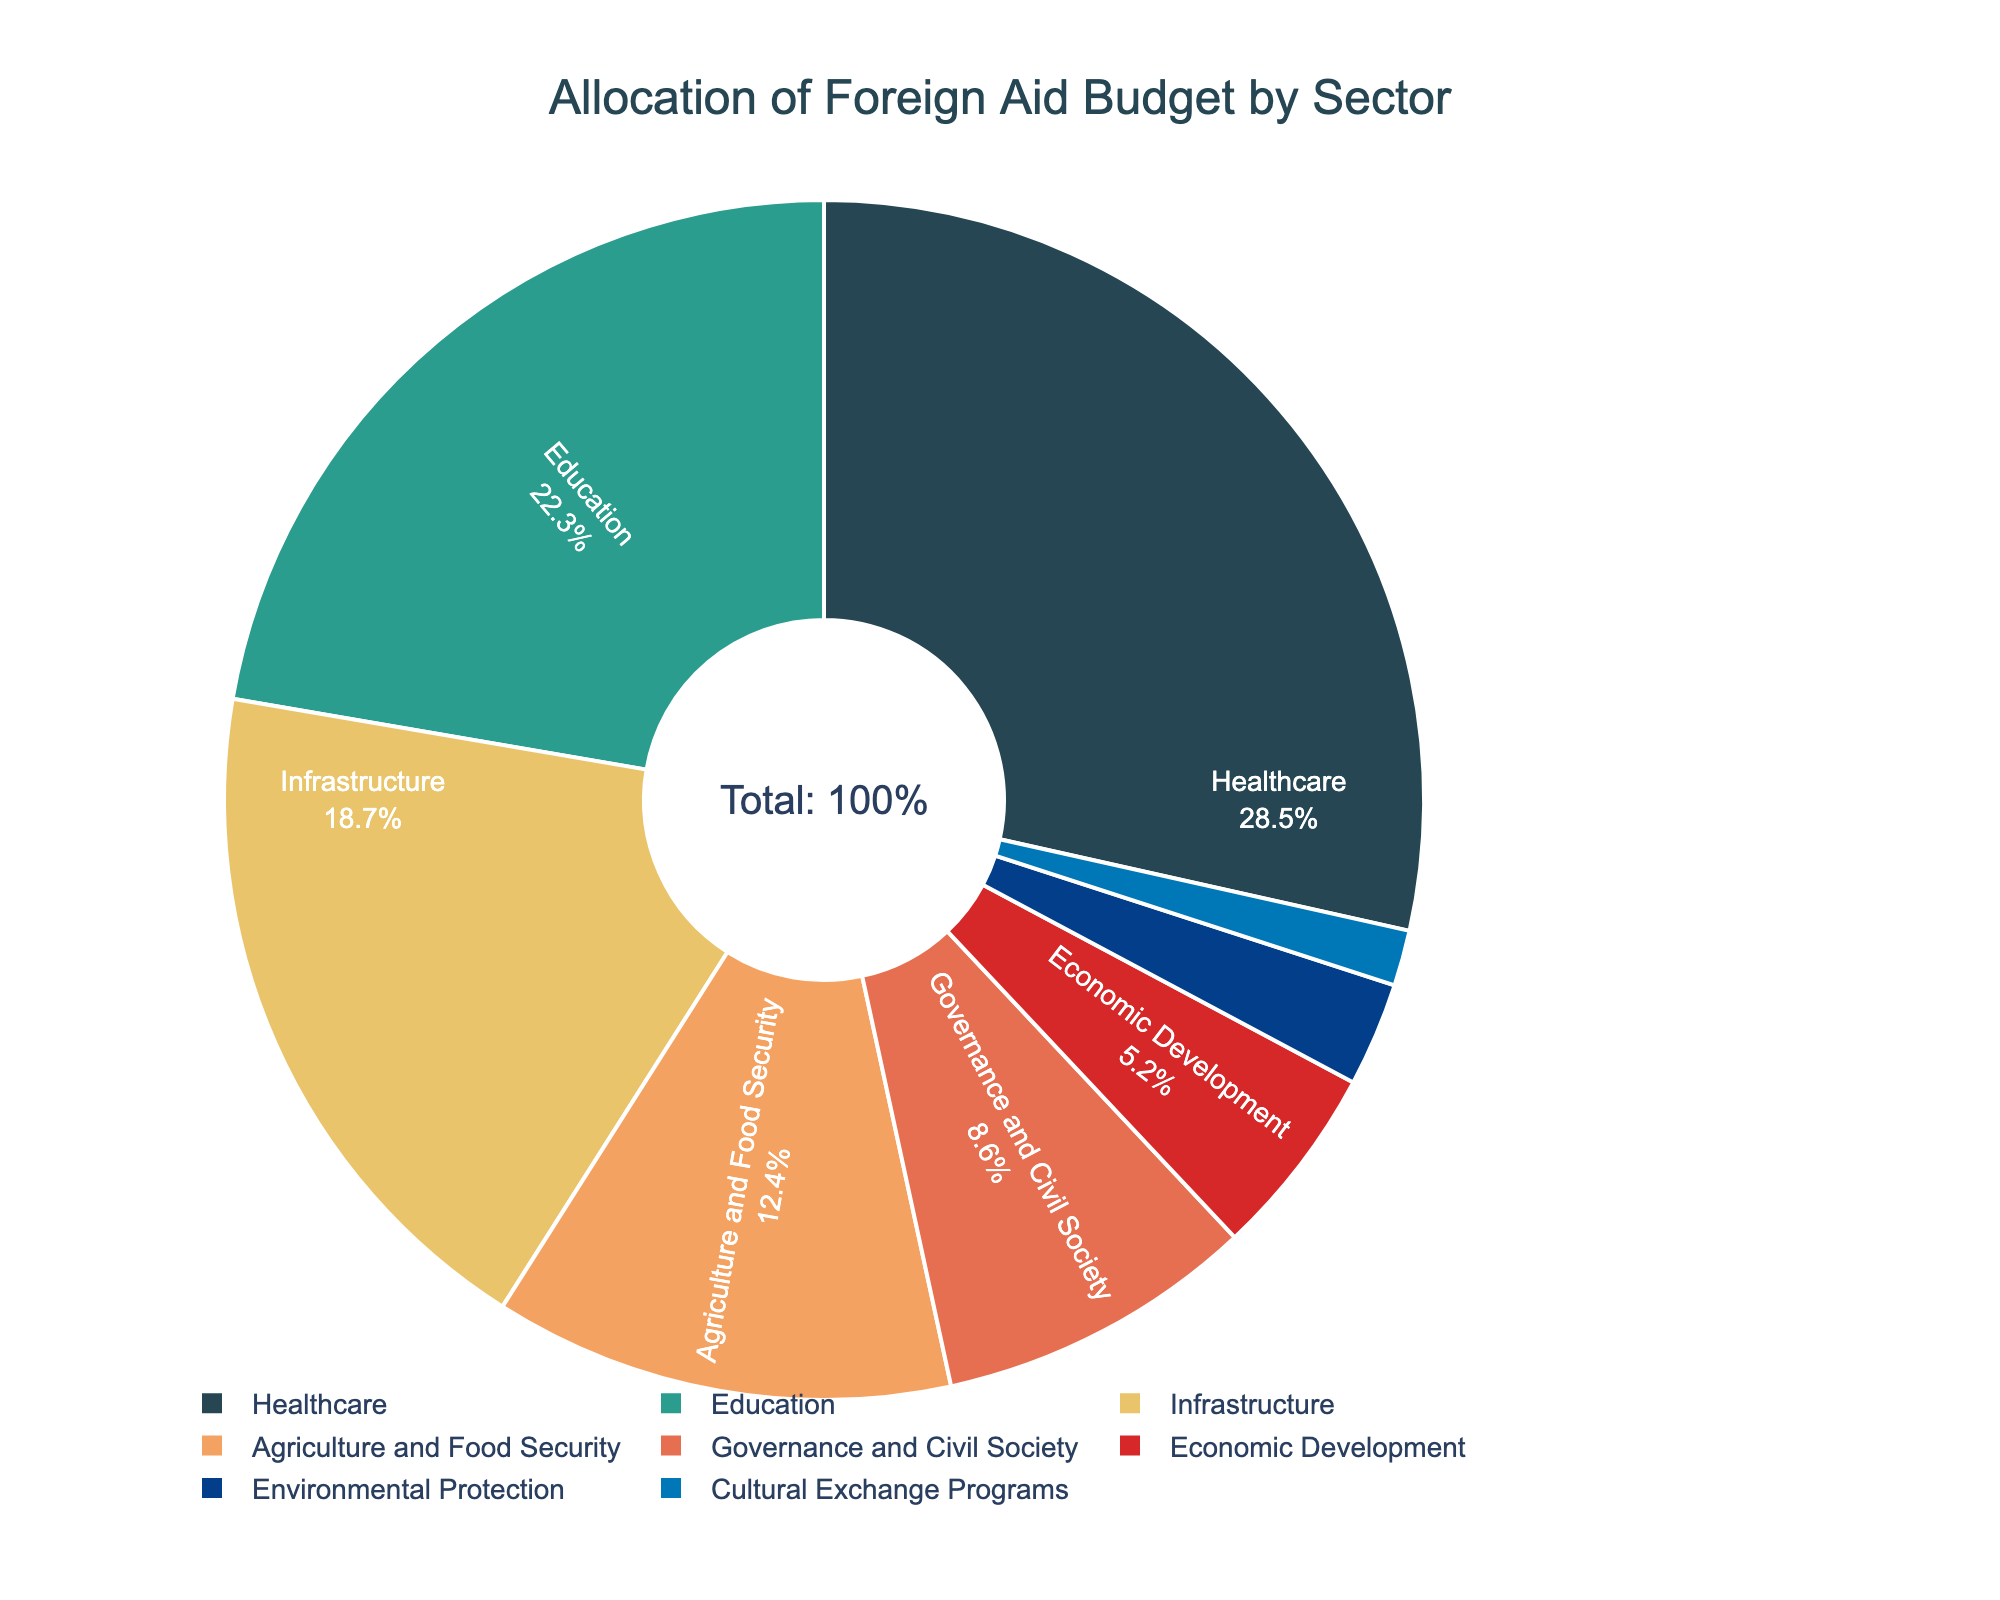What percentage of the foreign aid budget is allocated to Healthcare? The figure shows the percentage of the budget allocated to each sector. The slice representing Healthcare is labeled with its percentage.
Answer: 28.5% Which sector receives the smallest portion of the budget, and what percentage is it? The sectors are labeled with their percentages, and the smallest slice represents Cultural Exchange Programs.
Answer: Cultural Exchange Programs, 1.5% What is the combined allocation for Agriculture and Food Security, and Governance and Civil Society? Add the percentages of Agriculture and Food Security (12.4%) and Governance and Civil Society (8.6%) together. 12.4 + 8.6 = 21
Answer: 21% How much more budget percentage is allocated to Healthcare than Infrastructure? Subtract the percentage allocated to Infrastructure (18.7%) from the percentage allocated to Healthcare (28.5%). 28.5 - 18.7 = 9.8
Answer: 9.8% Which sector has a greater budget allocation: Economic Development or Environmental Protection? Compare the percentages for Economic Development (5.2%) and Environmental Protection (2.8%). 5.2 is greater than 2.8
Answer: Economic Development Identify two sectors whose combined budget allocation equals the allocation for Healthcare. By looking at combinations of sectors, we find that Education (22.3%) and Economic Development (5.2%) sum up to Healthcare's percentage. 22.3 + 5.2 = 27.5
Answer: Education and Economic Development What is the ratio of the budget allocation for Education to that of Cultural Exchange Programs? Divide the percentage allocation for Education (22.3%) by the percentage for Cultural Exchange Programs (1.5%). 22.3 / 1.5 ≈ 14.87
Answer: 14.87:1 How does the allocation for Governance and Civil Society compare to the allocation for Agriculture and Food Security? Compare the percentages for Agriculture and Food Security (12.4%) and Governance and Civil Society (8.6%). 12.4 is larger than 8.6
Answer: Agriculture and Food Security has more What is the total percentage allocation for sectors other than Healthcare? Subtract the percentage allocated to Healthcare (28.5%) from the total budget (100%). 100 - 28.5 = 71.5
Answer: 71.5% Arrange the sectors in descending order of their percentage allocation. The sectors are ordered by their represented percentages in the pie chart: Healthcare (28.5%), Education (22.3%), Infrastructure (18.7%), Agriculture and Food Security (12.4%), Governance and Civil Society (8.6%), Economic Development (5.2%), Environmental Protection (2.8%), Cultural Exchange Programs (1.5%)
Answer: Healthcare, Education, Infrastructure, Agriculture and Food Security, Governance and Civil Society, Economic Development, Environmental Protection, Cultural Exchange Programs 